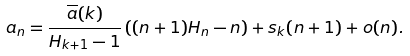<formula> <loc_0><loc_0><loc_500><loc_500>a _ { n } & = \frac { \overline { a } ( k ) } { H _ { k + 1 } - 1 } \left ( ( n + 1 ) H _ { n } - n \right ) + s _ { k } ( n + 1 ) + o ( n ) .</formula> 